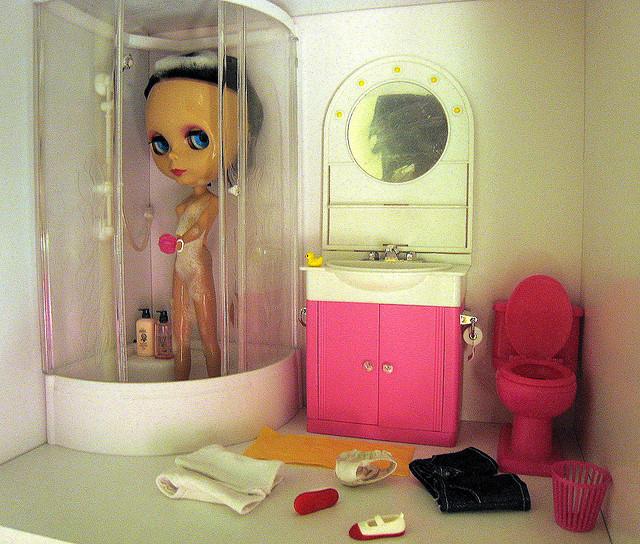Could this have been in a dollhouse?
Give a very brief answer. Yes. Is this a real bathroom?
Keep it brief. No. What is the doll doing?
Give a very brief answer. Showering. 